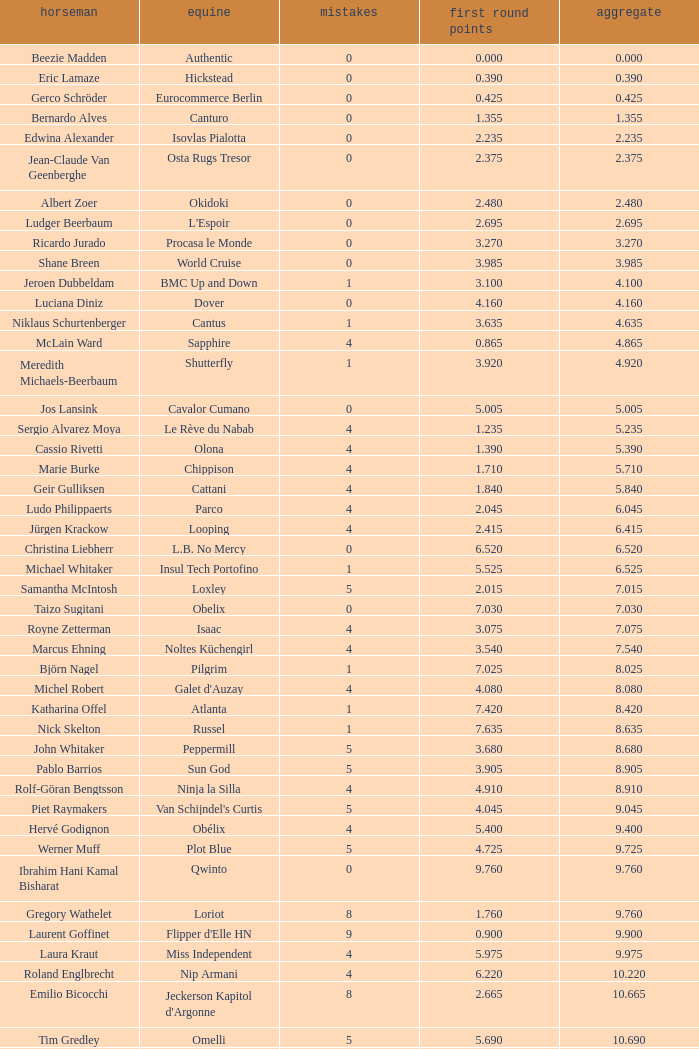Tell me the most total for horse of carlson 29.545. 